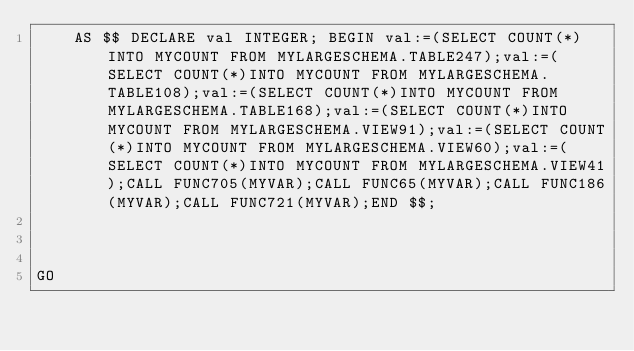Convert code to text. <code><loc_0><loc_0><loc_500><loc_500><_SQL_>    AS $$ DECLARE val INTEGER; BEGIN val:=(SELECT COUNT(*)INTO MYCOUNT FROM MYLARGESCHEMA.TABLE247);val:=(SELECT COUNT(*)INTO MYCOUNT FROM MYLARGESCHEMA.TABLE108);val:=(SELECT COUNT(*)INTO MYCOUNT FROM MYLARGESCHEMA.TABLE168);val:=(SELECT COUNT(*)INTO MYCOUNT FROM MYLARGESCHEMA.VIEW91);val:=(SELECT COUNT(*)INTO MYCOUNT FROM MYLARGESCHEMA.VIEW60);val:=(SELECT COUNT(*)INTO MYCOUNT FROM MYLARGESCHEMA.VIEW41);CALL FUNC705(MYVAR);CALL FUNC65(MYVAR);CALL FUNC186(MYVAR);CALL FUNC721(MYVAR);END $$;



GO</code> 